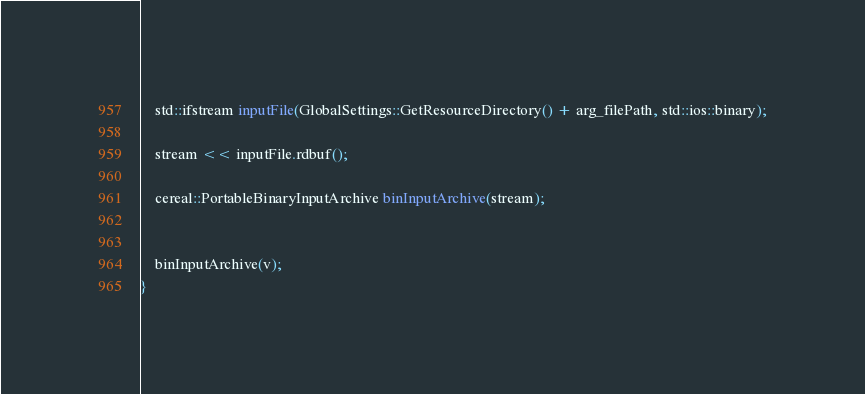<code> <loc_0><loc_0><loc_500><loc_500><_C++_>
	std::ifstream inputFile(GlobalSettings::GetResourceDirectory() + arg_filePath, std::ios::binary);

	stream << inputFile.rdbuf();

	cereal::PortableBinaryInputArchive binInputArchive(stream);


	binInputArchive(v);
}
</code> 